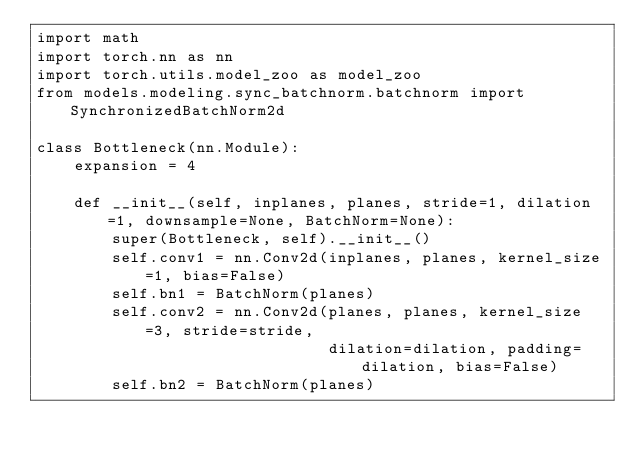Convert code to text. <code><loc_0><loc_0><loc_500><loc_500><_Python_>import math
import torch.nn as nn
import torch.utils.model_zoo as model_zoo
from models.modeling.sync_batchnorm.batchnorm import SynchronizedBatchNorm2d

class Bottleneck(nn.Module):
    expansion = 4

    def __init__(self, inplanes, planes, stride=1, dilation=1, downsample=None, BatchNorm=None):
        super(Bottleneck, self).__init__()
        self.conv1 = nn.Conv2d(inplanes, planes, kernel_size=1, bias=False)
        self.bn1 = BatchNorm(planes)
        self.conv2 = nn.Conv2d(planes, planes, kernel_size=3, stride=stride,
                               dilation=dilation, padding=dilation, bias=False)
        self.bn2 = BatchNorm(planes)</code> 